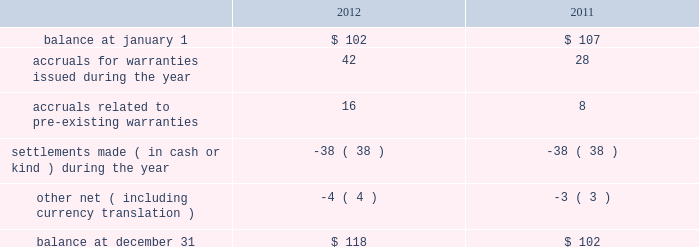Masco corporation notes to consolidated financial statements ( continued ) t .
Other commitments and contingencies litigation .
We are subject to claims , charges , litigation and other proceedings in the ordinary course of our business , including those arising from or related to contractual matters , intellectual property , personal injury , environmental matters , product liability , construction defect , insurance coverage , personnel and employment disputes and other matters , including class actions .
We believe we have adequate defenses in these matters and that the outcome of these matters is not likely to have a material adverse effect on us .
However , there is no assurance that we will prevail in these matters , and we could in the future incur judgments , enter into settlements of claims or revise our expectations regarding the outcome of these matters , which could materially impact our results of operations .
In july 2012 , the company reached a settlement agreement related to the columbus drywall litigation .
The company and its insulation installation companies named in the suit agreed to pay $ 75 million in return for dismissal with prejudice and full release of all claims .
The company and its insulation installation companies continue to deny that the challenged conduct was unlawful and admit no wrongdoing as part of the settlement .
A settlement was reached to eliminate the considerable expense and uncertainty of this lawsuit .
The company recorded the settlement expense in the second quarter of 2012 and the amount was paid in the fourth quarter of 2012 .
Warranty .
At the time of sale , the company accrues a warranty liability for the estimated cost to provide products , parts or services to repair or replace products in satisfaction of warranty obligations .
During the third quarter of 2012 , a business in the other specialty products segment recorded a $ 12 million increase in expected future warranty claims resulting from the completion of an analysis prepared by the company based upon its periodic assessment of recent business unit specific operating trends including , among others , home ownership demographics , sales volumes , manufacturing quality , an analysis of recent warranty claim activity and an estimate of current costs to service anticipated claims .
Changes in the company 2019s warranty liability were as follows , in millions: .
Investments .
With respect to the company 2019s investments in private equity funds , the company had , at december 31 , 2012 , commitments to contribute up to $ 19 million of additional capital to such funds representing the company 2019s aggregate capital commitment to such funds less capital contributions made to date .
The company is contractually obligated to make additional capital contributions to certain of its private equity funds upon receipt of a capital call from the private equity fund .
The company has no control over when or if the capital calls will occur .
Capital calls are funded in cash and generally result in an increase in the carrying value of the company 2019s investment in the private equity fund when paid. .
What was the percent of the change in the accruals for warranties issued from 2011 to 2012? 
Rationale: the accruals for warranties issued increased by 50% from 2011 to 2012
Computations: ((42 - 28) / 28)
Answer: 0.5. 